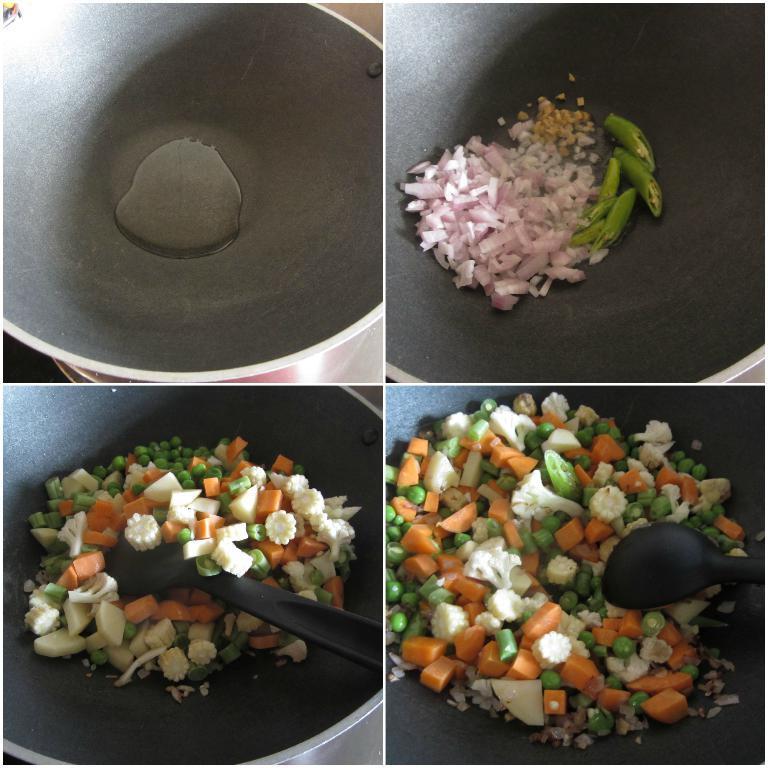How would you summarize this image in a sentence or two? This is the collage image of some food items in containers. 